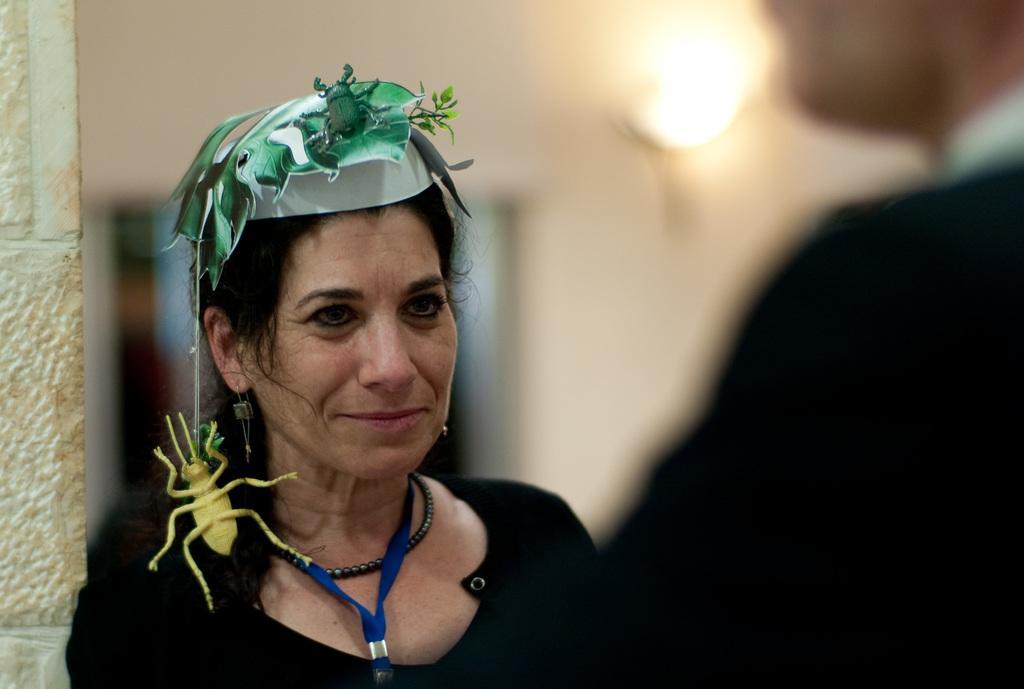Could you give a brief overview of what you see in this image? In this image I can see a woman wearing black colored dress and on her head I can see a mask which is green in color. I can see a person in front of her and the blurry background in which I can see the wall and a light. 